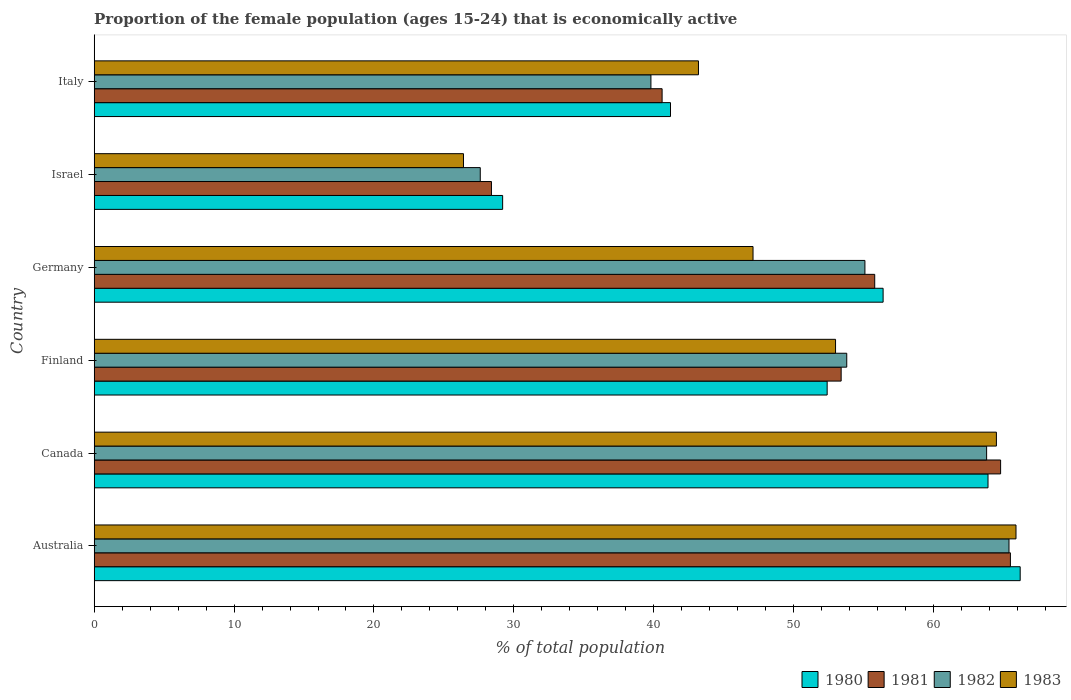How many groups of bars are there?
Provide a short and direct response. 6. How many bars are there on the 6th tick from the top?
Give a very brief answer. 4. How many bars are there on the 4th tick from the bottom?
Your answer should be compact. 4. What is the label of the 3rd group of bars from the top?
Give a very brief answer. Germany. In how many cases, is the number of bars for a given country not equal to the number of legend labels?
Make the answer very short. 0. What is the proportion of the female population that is economically active in 1980 in Australia?
Provide a short and direct response. 66.2. Across all countries, what is the maximum proportion of the female population that is economically active in 1981?
Give a very brief answer. 65.5. Across all countries, what is the minimum proportion of the female population that is economically active in 1982?
Give a very brief answer. 27.6. In which country was the proportion of the female population that is economically active in 1980 maximum?
Your answer should be very brief. Australia. In which country was the proportion of the female population that is economically active in 1983 minimum?
Your answer should be compact. Israel. What is the total proportion of the female population that is economically active in 1983 in the graph?
Ensure brevity in your answer.  300.1. What is the difference between the proportion of the female population that is economically active in 1980 in Australia and that in Canada?
Provide a short and direct response. 2.3. What is the difference between the proportion of the female population that is economically active in 1981 in Australia and the proportion of the female population that is economically active in 1983 in Israel?
Your answer should be compact. 39.1. What is the average proportion of the female population that is economically active in 1982 per country?
Your answer should be very brief. 50.92. What is the difference between the proportion of the female population that is economically active in 1982 and proportion of the female population that is economically active in 1983 in Canada?
Your answer should be very brief. -0.7. In how many countries, is the proportion of the female population that is economically active in 1980 greater than 36 %?
Your answer should be compact. 5. What is the ratio of the proportion of the female population that is economically active in 1982 in Finland to that in Germany?
Make the answer very short. 0.98. Is the difference between the proportion of the female population that is economically active in 1982 in Australia and Germany greater than the difference between the proportion of the female population that is economically active in 1983 in Australia and Germany?
Offer a very short reply. No. What is the difference between the highest and the second highest proportion of the female population that is economically active in 1982?
Make the answer very short. 1.6. What is the difference between the highest and the lowest proportion of the female population that is economically active in 1983?
Ensure brevity in your answer.  39.5. In how many countries, is the proportion of the female population that is economically active in 1981 greater than the average proportion of the female population that is economically active in 1981 taken over all countries?
Offer a very short reply. 4. Is the sum of the proportion of the female population that is economically active in 1980 in Canada and Finland greater than the maximum proportion of the female population that is economically active in 1983 across all countries?
Your response must be concise. Yes. What does the 3rd bar from the top in Canada represents?
Make the answer very short. 1981. What does the 2nd bar from the bottom in Australia represents?
Make the answer very short. 1981. Is it the case that in every country, the sum of the proportion of the female population that is economically active in 1983 and proportion of the female population that is economically active in 1981 is greater than the proportion of the female population that is economically active in 1982?
Provide a short and direct response. Yes. How many bars are there?
Your answer should be very brief. 24. What is the difference between two consecutive major ticks on the X-axis?
Your answer should be compact. 10. Are the values on the major ticks of X-axis written in scientific E-notation?
Give a very brief answer. No. Does the graph contain grids?
Provide a succinct answer. No. Where does the legend appear in the graph?
Your answer should be very brief. Bottom right. How many legend labels are there?
Your response must be concise. 4. What is the title of the graph?
Your answer should be very brief. Proportion of the female population (ages 15-24) that is economically active. What is the label or title of the X-axis?
Provide a succinct answer. % of total population. What is the label or title of the Y-axis?
Provide a succinct answer. Country. What is the % of total population of 1980 in Australia?
Ensure brevity in your answer.  66.2. What is the % of total population in 1981 in Australia?
Your response must be concise. 65.5. What is the % of total population in 1982 in Australia?
Keep it short and to the point. 65.4. What is the % of total population in 1983 in Australia?
Give a very brief answer. 65.9. What is the % of total population of 1980 in Canada?
Offer a terse response. 63.9. What is the % of total population in 1981 in Canada?
Offer a very short reply. 64.8. What is the % of total population in 1982 in Canada?
Give a very brief answer. 63.8. What is the % of total population of 1983 in Canada?
Your answer should be very brief. 64.5. What is the % of total population in 1980 in Finland?
Give a very brief answer. 52.4. What is the % of total population of 1981 in Finland?
Keep it short and to the point. 53.4. What is the % of total population of 1982 in Finland?
Your answer should be compact. 53.8. What is the % of total population in 1980 in Germany?
Offer a terse response. 56.4. What is the % of total population in 1981 in Germany?
Keep it short and to the point. 55.8. What is the % of total population of 1982 in Germany?
Give a very brief answer. 55.1. What is the % of total population in 1983 in Germany?
Provide a succinct answer. 47.1. What is the % of total population of 1980 in Israel?
Offer a terse response. 29.2. What is the % of total population in 1981 in Israel?
Your response must be concise. 28.4. What is the % of total population in 1982 in Israel?
Keep it short and to the point. 27.6. What is the % of total population in 1983 in Israel?
Your answer should be very brief. 26.4. What is the % of total population in 1980 in Italy?
Offer a very short reply. 41.2. What is the % of total population in 1981 in Italy?
Make the answer very short. 40.6. What is the % of total population of 1982 in Italy?
Ensure brevity in your answer.  39.8. What is the % of total population of 1983 in Italy?
Your response must be concise. 43.2. Across all countries, what is the maximum % of total population in 1980?
Ensure brevity in your answer.  66.2. Across all countries, what is the maximum % of total population of 1981?
Provide a succinct answer. 65.5. Across all countries, what is the maximum % of total population of 1982?
Offer a very short reply. 65.4. Across all countries, what is the maximum % of total population in 1983?
Offer a terse response. 65.9. Across all countries, what is the minimum % of total population of 1980?
Offer a very short reply. 29.2. Across all countries, what is the minimum % of total population of 1981?
Offer a very short reply. 28.4. Across all countries, what is the minimum % of total population in 1982?
Provide a short and direct response. 27.6. Across all countries, what is the minimum % of total population in 1983?
Your answer should be compact. 26.4. What is the total % of total population in 1980 in the graph?
Provide a short and direct response. 309.3. What is the total % of total population in 1981 in the graph?
Provide a short and direct response. 308.5. What is the total % of total population of 1982 in the graph?
Keep it short and to the point. 305.5. What is the total % of total population of 1983 in the graph?
Your response must be concise. 300.1. What is the difference between the % of total population of 1982 in Australia and that in Canada?
Your answer should be compact. 1.6. What is the difference between the % of total population of 1983 in Australia and that in Canada?
Your answer should be compact. 1.4. What is the difference between the % of total population in 1982 in Australia and that in Finland?
Ensure brevity in your answer.  11.6. What is the difference between the % of total population in 1981 in Australia and that in Germany?
Make the answer very short. 9.7. What is the difference between the % of total population in 1982 in Australia and that in Germany?
Your answer should be very brief. 10.3. What is the difference between the % of total population of 1980 in Australia and that in Israel?
Provide a short and direct response. 37. What is the difference between the % of total population of 1981 in Australia and that in Israel?
Give a very brief answer. 37.1. What is the difference between the % of total population of 1982 in Australia and that in Israel?
Provide a short and direct response. 37.8. What is the difference between the % of total population in 1983 in Australia and that in Israel?
Offer a terse response. 39.5. What is the difference between the % of total population of 1981 in Australia and that in Italy?
Make the answer very short. 24.9. What is the difference between the % of total population in 1982 in Australia and that in Italy?
Provide a succinct answer. 25.6. What is the difference between the % of total population in 1983 in Australia and that in Italy?
Provide a short and direct response. 22.7. What is the difference between the % of total population of 1980 in Canada and that in Finland?
Offer a terse response. 11.5. What is the difference between the % of total population of 1982 in Canada and that in Finland?
Ensure brevity in your answer.  10. What is the difference between the % of total population in 1983 in Canada and that in Germany?
Provide a short and direct response. 17.4. What is the difference between the % of total population in 1980 in Canada and that in Israel?
Provide a short and direct response. 34.7. What is the difference between the % of total population in 1981 in Canada and that in Israel?
Provide a short and direct response. 36.4. What is the difference between the % of total population of 1982 in Canada and that in Israel?
Provide a succinct answer. 36.2. What is the difference between the % of total population of 1983 in Canada and that in Israel?
Your response must be concise. 38.1. What is the difference between the % of total population of 1980 in Canada and that in Italy?
Offer a very short reply. 22.7. What is the difference between the % of total population of 1981 in Canada and that in Italy?
Provide a short and direct response. 24.2. What is the difference between the % of total population of 1982 in Canada and that in Italy?
Your response must be concise. 24. What is the difference between the % of total population in 1983 in Canada and that in Italy?
Offer a terse response. 21.3. What is the difference between the % of total population in 1980 in Finland and that in Germany?
Offer a terse response. -4. What is the difference between the % of total population in 1980 in Finland and that in Israel?
Provide a succinct answer. 23.2. What is the difference between the % of total population in 1982 in Finland and that in Israel?
Offer a terse response. 26.2. What is the difference between the % of total population in 1983 in Finland and that in Israel?
Your answer should be compact. 26.6. What is the difference between the % of total population of 1981 in Finland and that in Italy?
Provide a succinct answer. 12.8. What is the difference between the % of total population in 1982 in Finland and that in Italy?
Your answer should be compact. 14. What is the difference between the % of total population in 1983 in Finland and that in Italy?
Ensure brevity in your answer.  9.8. What is the difference between the % of total population in 1980 in Germany and that in Israel?
Make the answer very short. 27.2. What is the difference between the % of total population of 1981 in Germany and that in Israel?
Offer a very short reply. 27.4. What is the difference between the % of total population of 1983 in Germany and that in Israel?
Offer a terse response. 20.7. What is the difference between the % of total population of 1980 in Israel and that in Italy?
Provide a short and direct response. -12. What is the difference between the % of total population of 1982 in Israel and that in Italy?
Offer a terse response. -12.2. What is the difference between the % of total population of 1983 in Israel and that in Italy?
Provide a succinct answer. -16.8. What is the difference between the % of total population of 1980 in Australia and the % of total population of 1981 in Canada?
Your response must be concise. 1.4. What is the difference between the % of total population of 1980 in Australia and the % of total population of 1982 in Canada?
Your answer should be compact. 2.4. What is the difference between the % of total population in 1981 in Australia and the % of total population in 1982 in Canada?
Keep it short and to the point. 1.7. What is the difference between the % of total population in 1980 in Australia and the % of total population in 1983 in Finland?
Offer a terse response. 13.2. What is the difference between the % of total population in 1981 in Australia and the % of total population in 1982 in Finland?
Make the answer very short. 11.7. What is the difference between the % of total population of 1981 in Australia and the % of total population of 1983 in Finland?
Make the answer very short. 12.5. What is the difference between the % of total population in 1982 in Australia and the % of total population in 1983 in Finland?
Ensure brevity in your answer.  12.4. What is the difference between the % of total population of 1980 in Australia and the % of total population of 1981 in Germany?
Provide a succinct answer. 10.4. What is the difference between the % of total population in 1981 in Australia and the % of total population in 1983 in Germany?
Offer a very short reply. 18.4. What is the difference between the % of total population of 1980 in Australia and the % of total population of 1981 in Israel?
Make the answer very short. 37.8. What is the difference between the % of total population of 1980 in Australia and the % of total population of 1982 in Israel?
Your answer should be compact. 38.6. What is the difference between the % of total population in 1980 in Australia and the % of total population in 1983 in Israel?
Keep it short and to the point. 39.8. What is the difference between the % of total population of 1981 in Australia and the % of total population of 1982 in Israel?
Give a very brief answer. 37.9. What is the difference between the % of total population in 1981 in Australia and the % of total population in 1983 in Israel?
Offer a very short reply. 39.1. What is the difference between the % of total population of 1980 in Australia and the % of total population of 1981 in Italy?
Your answer should be very brief. 25.6. What is the difference between the % of total population of 1980 in Australia and the % of total population of 1982 in Italy?
Provide a succinct answer. 26.4. What is the difference between the % of total population of 1980 in Australia and the % of total population of 1983 in Italy?
Provide a short and direct response. 23. What is the difference between the % of total population of 1981 in Australia and the % of total population of 1982 in Italy?
Give a very brief answer. 25.7. What is the difference between the % of total population of 1981 in Australia and the % of total population of 1983 in Italy?
Your answer should be compact. 22.3. What is the difference between the % of total population in 1982 in Australia and the % of total population in 1983 in Italy?
Ensure brevity in your answer.  22.2. What is the difference between the % of total population of 1980 in Canada and the % of total population of 1981 in Finland?
Offer a terse response. 10.5. What is the difference between the % of total population in 1982 in Canada and the % of total population in 1983 in Finland?
Provide a short and direct response. 10.8. What is the difference between the % of total population of 1980 in Canada and the % of total population of 1982 in Germany?
Provide a succinct answer. 8.8. What is the difference between the % of total population in 1982 in Canada and the % of total population in 1983 in Germany?
Provide a short and direct response. 16.7. What is the difference between the % of total population in 1980 in Canada and the % of total population in 1981 in Israel?
Your response must be concise. 35.5. What is the difference between the % of total population of 1980 in Canada and the % of total population of 1982 in Israel?
Your answer should be very brief. 36.3. What is the difference between the % of total population in 1980 in Canada and the % of total population in 1983 in Israel?
Offer a terse response. 37.5. What is the difference between the % of total population in 1981 in Canada and the % of total population in 1982 in Israel?
Make the answer very short. 37.2. What is the difference between the % of total population of 1981 in Canada and the % of total population of 1983 in Israel?
Your response must be concise. 38.4. What is the difference between the % of total population in 1982 in Canada and the % of total population in 1983 in Israel?
Offer a very short reply. 37.4. What is the difference between the % of total population of 1980 in Canada and the % of total population of 1981 in Italy?
Your answer should be compact. 23.3. What is the difference between the % of total population in 1980 in Canada and the % of total population in 1982 in Italy?
Your answer should be very brief. 24.1. What is the difference between the % of total population in 1980 in Canada and the % of total population in 1983 in Italy?
Ensure brevity in your answer.  20.7. What is the difference between the % of total population in 1981 in Canada and the % of total population in 1983 in Italy?
Keep it short and to the point. 21.6. What is the difference between the % of total population in 1982 in Canada and the % of total population in 1983 in Italy?
Offer a terse response. 20.6. What is the difference between the % of total population in 1980 in Finland and the % of total population in 1981 in Germany?
Give a very brief answer. -3.4. What is the difference between the % of total population of 1980 in Finland and the % of total population of 1983 in Germany?
Offer a very short reply. 5.3. What is the difference between the % of total population of 1982 in Finland and the % of total population of 1983 in Germany?
Keep it short and to the point. 6.7. What is the difference between the % of total population of 1980 in Finland and the % of total population of 1981 in Israel?
Ensure brevity in your answer.  24. What is the difference between the % of total population of 1980 in Finland and the % of total population of 1982 in Israel?
Ensure brevity in your answer.  24.8. What is the difference between the % of total population in 1981 in Finland and the % of total population in 1982 in Israel?
Your answer should be very brief. 25.8. What is the difference between the % of total population in 1981 in Finland and the % of total population in 1983 in Israel?
Offer a terse response. 27. What is the difference between the % of total population of 1982 in Finland and the % of total population of 1983 in Israel?
Your answer should be very brief. 27.4. What is the difference between the % of total population of 1980 in Finland and the % of total population of 1982 in Italy?
Your answer should be very brief. 12.6. What is the difference between the % of total population of 1981 in Finland and the % of total population of 1982 in Italy?
Make the answer very short. 13.6. What is the difference between the % of total population of 1980 in Germany and the % of total population of 1981 in Israel?
Your answer should be very brief. 28. What is the difference between the % of total population of 1980 in Germany and the % of total population of 1982 in Israel?
Make the answer very short. 28.8. What is the difference between the % of total population of 1981 in Germany and the % of total population of 1982 in Israel?
Keep it short and to the point. 28.2. What is the difference between the % of total population of 1981 in Germany and the % of total population of 1983 in Israel?
Give a very brief answer. 29.4. What is the difference between the % of total population in 1982 in Germany and the % of total population in 1983 in Israel?
Make the answer very short. 28.7. What is the difference between the % of total population of 1980 in Germany and the % of total population of 1981 in Italy?
Provide a short and direct response. 15.8. What is the difference between the % of total population in 1980 in Germany and the % of total population in 1982 in Italy?
Your answer should be very brief. 16.6. What is the difference between the % of total population in 1980 in Germany and the % of total population in 1983 in Italy?
Offer a terse response. 13.2. What is the difference between the % of total population in 1981 in Israel and the % of total population in 1982 in Italy?
Make the answer very short. -11.4. What is the difference between the % of total population in 1981 in Israel and the % of total population in 1983 in Italy?
Offer a terse response. -14.8. What is the difference between the % of total population of 1982 in Israel and the % of total population of 1983 in Italy?
Offer a very short reply. -15.6. What is the average % of total population of 1980 per country?
Ensure brevity in your answer.  51.55. What is the average % of total population in 1981 per country?
Give a very brief answer. 51.42. What is the average % of total population in 1982 per country?
Provide a succinct answer. 50.92. What is the average % of total population of 1983 per country?
Provide a short and direct response. 50.02. What is the difference between the % of total population of 1980 and % of total population of 1982 in Australia?
Ensure brevity in your answer.  0.8. What is the difference between the % of total population of 1981 and % of total population of 1982 in Australia?
Offer a very short reply. 0.1. What is the difference between the % of total population in 1980 and % of total population in 1983 in Canada?
Provide a short and direct response. -0.6. What is the difference between the % of total population of 1981 and % of total population of 1982 in Canada?
Make the answer very short. 1. What is the difference between the % of total population in 1981 and % of total population in 1983 in Canada?
Your answer should be very brief. 0.3. What is the difference between the % of total population of 1982 and % of total population of 1983 in Canada?
Offer a very short reply. -0.7. What is the difference between the % of total population in 1980 and % of total population in 1981 in Finland?
Keep it short and to the point. -1. What is the difference between the % of total population of 1980 and % of total population of 1982 in Finland?
Offer a terse response. -1.4. What is the difference between the % of total population in 1980 and % of total population in 1983 in Finland?
Your answer should be compact. -0.6. What is the difference between the % of total population in 1981 and % of total population in 1983 in Finland?
Keep it short and to the point. 0.4. What is the difference between the % of total population in 1982 and % of total population in 1983 in Finland?
Make the answer very short. 0.8. What is the difference between the % of total population of 1980 and % of total population of 1982 in Germany?
Your answer should be compact. 1.3. What is the difference between the % of total population in 1981 and % of total population in 1983 in Germany?
Offer a terse response. 8.7. What is the difference between the % of total population of 1980 and % of total population of 1983 in Israel?
Offer a terse response. 2.8. What is the difference between the % of total population in 1981 and % of total population in 1982 in Israel?
Your answer should be compact. 0.8. What is the difference between the % of total population in 1981 and % of total population in 1983 in Israel?
Your answer should be very brief. 2. What is the difference between the % of total population in 1982 and % of total population in 1983 in Israel?
Keep it short and to the point. 1.2. What is the difference between the % of total population in 1980 and % of total population in 1983 in Italy?
Your answer should be very brief. -2. What is the difference between the % of total population in 1981 and % of total population in 1982 in Italy?
Your answer should be compact. 0.8. What is the difference between the % of total population of 1981 and % of total population of 1983 in Italy?
Give a very brief answer. -2.6. What is the difference between the % of total population in 1982 and % of total population in 1983 in Italy?
Keep it short and to the point. -3.4. What is the ratio of the % of total population of 1980 in Australia to that in Canada?
Offer a terse response. 1.04. What is the ratio of the % of total population of 1981 in Australia to that in Canada?
Ensure brevity in your answer.  1.01. What is the ratio of the % of total population of 1982 in Australia to that in Canada?
Your response must be concise. 1.03. What is the ratio of the % of total population in 1983 in Australia to that in Canada?
Offer a very short reply. 1.02. What is the ratio of the % of total population of 1980 in Australia to that in Finland?
Give a very brief answer. 1.26. What is the ratio of the % of total population in 1981 in Australia to that in Finland?
Your response must be concise. 1.23. What is the ratio of the % of total population of 1982 in Australia to that in Finland?
Your answer should be compact. 1.22. What is the ratio of the % of total population of 1983 in Australia to that in Finland?
Give a very brief answer. 1.24. What is the ratio of the % of total population in 1980 in Australia to that in Germany?
Provide a succinct answer. 1.17. What is the ratio of the % of total population of 1981 in Australia to that in Germany?
Provide a short and direct response. 1.17. What is the ratio of the % of total population of 1982 in Australia to that in Germany?
Give a very brief answer. 1.19. What is the ratio of the % of total population in 1983 in Australia to that in Germany?
Make the answer very short. 1.4. What is the ratio of the % of total population in 1980 in Australia to that in Israel?
Your answer should be compact. 2.27. What is the ratio of the % of total population in 1981 in Australia to that in Israel?
Provide a short and direct response. 2.31. What is the ratio of the % of total population of 1982 in Australia to that in Israel?
Give a very brief answer. 2.37. What is the ratio of the % of total population of 1983 in Australia to that in Israel?
Offer a very short reply. 2.5. What is the ratio of the % of total population in 1980 in Australia to that in Italy?
Offer a very short reply. 1.61. What is the ratio of the % of total population of 1981 in Australia to that in Italy?
Provide a short and direct response. 1.61. What is the ratio of the % of total population of 1982 in Australia to that in Italy?
Your answer should be compact. 1.64. What is the ratio of the % of total population in 1983 in Australia to that in Italy?
Your answer should be very brief. 1.53. What is the ratio of the % of total population of 1980 in Canada to that in Finland?
Offer a very short reply. 1.22. What is the ratio of the % of total population of 1981 in Canada to that in Finland?
Your answer should be very brief. 1.21. What is the ratio of the % of total population of 1982 in Canada to that in Finland?
Make the answer very short. 1.19. What is the ratio of the % of total population of 1983 in Canada to that in Finland?
Give a very brief answer. 1.22. What is the ratio of the % of total population of 1980 in Canada to that in Germany?
Make the answer very short. 1.13. What is the ratio of the % of total population of 1981 in Canada to that in Germany?
Make the answer very short. 1.16. What is the ratio of the % of total population of 1982 in Canada to that in Germany?
Provide a short and direct response. 1.16. What is the ratio of the % of total population in 1983 in Canada to that in Germany?
Make the answer very short. 1.37. What is the ratio of the % of total population in 1980 in Canada to that in Israel?
Make the answer very short. 2.19. What is the ratio of the % of total population in 1981 in Canada to that in Israel?
Your answer should be compact. 2.28. What is the ratio of the % of total population of 1982 in Canada to that in Israel?
Your answer should be compact. 2.31. What is the ratio of the % of total population of 1983 in Canada to that in Israel?
Ensure brevity in your answer.  2.44. What is the ratio of the % of total population in 1980 in Canada to that in Italy?
Provide a succinct answer. 1.55. What is the ratio of the % of total population in 1981 in Canada to that in Italy?
Offer a very short reply. 1.6. What is the ratio of the % of total population of 1982 in Canada to that in Italy?
Give a very brief answer. 1.6. What is the ratio of the % of total population of 1983 in Canada to that in Italy?
Provide a succinct answer. 1.49. What is the ratio of the % of total population of 1980 in Finland to that in Germany?
Provide a short and direct response. 0.93. What is the ratio of the % of total population in 1981 in Finland to that in Germany?
Offer a very short reply. 0.96. What is the ratio of the % of total population of 1982 in Finland to that in Germany?
Ensure brevity in your answer.  0.98. What is the ratio of the % of total population in 1983 in Finland to that in Germany?
Your response must be concise. 1.13. What is the ratio of the % of total population of 1980 in Finland to that in Israel?
Ensure brevity in your answer.  1.79. What is the ratio of the % of total population in 1981 in Finland to that in Israel?
Your response must be concise. 1.88. What is the ratio of the % of total population of 1982 in Finland to that in Israel?
Your answer should be compact. 1.95. What is the ratio of the % of total population in 1983 in Finland to that in Israel?
Provide a short and direct response. 2.01. What is the ratio of the % of total population in 1980 in Finland to that in Italy?
Your response must be concise. 1.27. What is the ratio of the % of total population in 1981 in Finland to that in Italy?
Provide a succinct answer. 1.32. What is the ratio of the % of total population in 1982 in Finland to that in Italy?
Offer a very short reply. 1.35. What is the ratio of the % of total population of 1983 in Finland to that in Italy?
Offer a very short reply. 1.23. What is the ratio of the % of total population in 1980 in Germany to that in Israel?
Your answer should be very brief. 1.93. What is the ratio of the % of total population of 1981 in Germany to that in Israel?
Make the answer very short. 1.96. What is the ratio of the % of total population in 1982 in Germany to that in Israel?
Your answer should be very brief. 2. What is the ratio of the % of total population of 1983 in Germany to that in Israel?
Keep it short and to the point. 1.78. What is the ratio of the % of total population in 1980 in Germany to that in Italy?
Your answer should be compact. 1.37. What is the ratio of the % of total population in 1981 in Germany to that in Italy?
Offer a very short reply. 1.37. What is the ratio of the % of total population in 1982 in Germany to that in Italy?
Ensure brevity in your answer.  1.38. What is the ratio of the % of total population in 1983 in Germany to that in Italy?
Your answer should be very brief. 1.09. What is the ratio of the % of total population of 1980 in Israel to that in Italy?
Give a very brief answer. 0.71. What is the ratio of the % of total population in 1981 in Israel to that in Italy?
Offer a terse response. 0.7. What is the ratio of the % of total population in 1982 in Israel to that in Italy?
Your response must be concise. 0.69. What is the ratio of the % of total population in 1983 in Israel to that in Italy?
Offer a terse response. 0.61. What is the difference between the highest and the second highest % of total population in 1980?
Keep it short and to the point. 2.3. What is the difference between the highest and the second highest % of total population in 1981?
Give a very brief answer. 0.7. What is the difference between the highest and the lowest % of total population of 1980?
Offer a terse response. 37. What is the difference between the highest and the lowest % of total population in 1981?
Your response must be concise. 37.1. What is the difference between the highest and the lowest % of total population of 1982?
Give a very brief answer. 37.8. What is the difference between the highest and the lowest % of total population of 1983?
Make the answer very short. 39.5. 